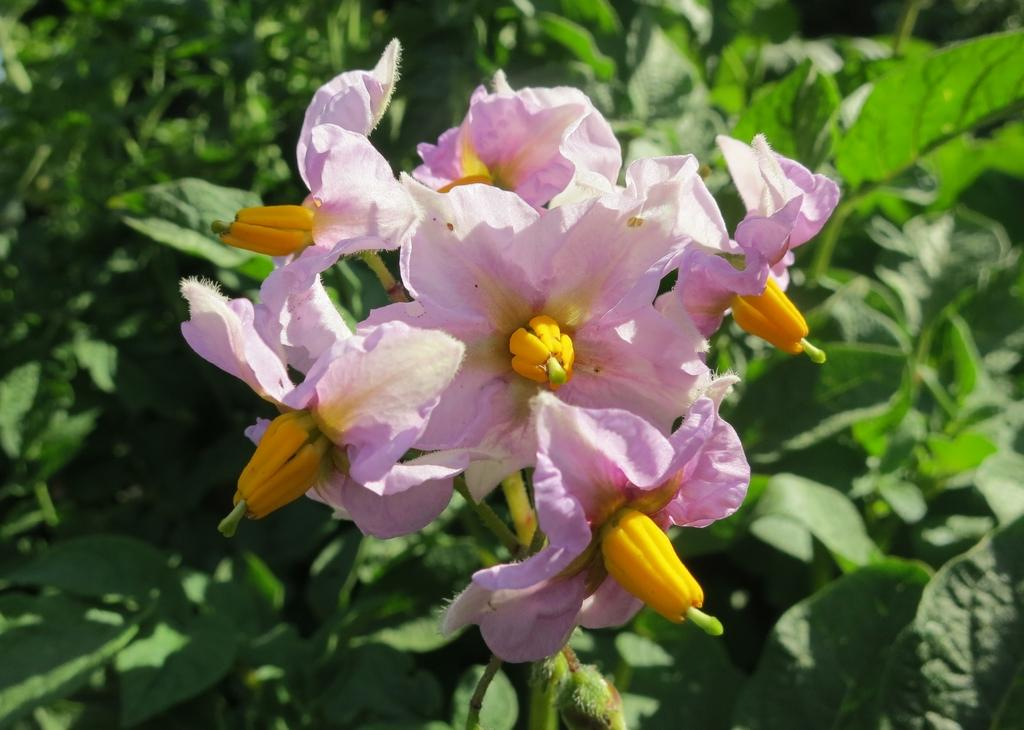What type of flowers are visible in the image? There are flowers with stems in the image. What else can be seen in the image besides the flowers? There are many plants visible behind the flowers. How many boys are playing with a hose near the sea in the image? There is no sea, boys, or hose present in the image. 